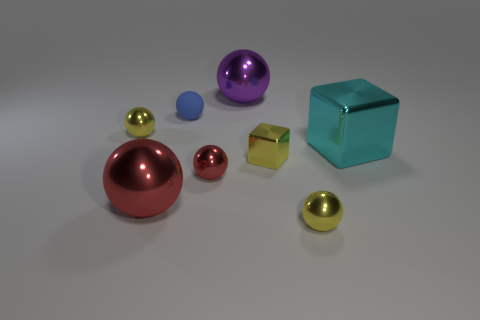Subtract all blue spheres. How many spheres are left? 5 Subtract all large balls. How many balls are left? 4 Subtract all gray balls. Subtract all brown cubes. How many balls are left? 6 Add 2 purple balls. How many objects exist? 10 Subtract all balls. How many objects are left? 2 Subtract all tiny red shiny objects. Subtract all large brown metal cylinders. How many objects are left? 7 Add 5 large red metal spheres. How many large red metal spheres are left? 6 Add 2 red balls. How many red balls exist? 4 Subtract 0 cyan spheres. How many objects are left? 8 